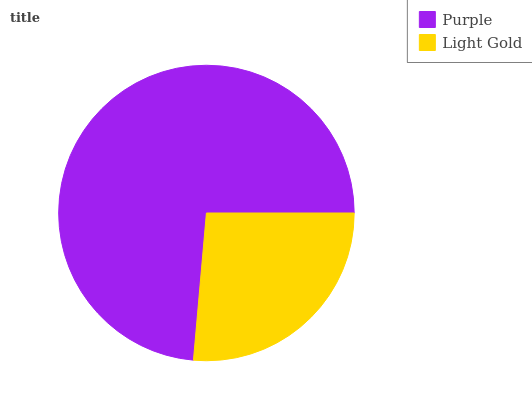Is Light Gold the minimum?
Answer yes or no. Yes. Is Purple the maximum?
Answer yes or no. Yes. Is Light Gold the maximum?
Answer yes or no. No. Is Purple greater than Light Gold?
Answer yes or no. Yes. Is Light Gold less than Purple?
Answer yes or no. Yes. Is Light Gold greater than Purple?
Answer yes or no. No. Is Purple less than Light Gold?
Answer yes or no. No. Is Purple the high median?
Answer yes or no. Yes. Is Light Gold the low median?
Answer yes or no. Yes. Is Light Gold the high median?
Answer yes or no. No. Is Purple the low median?
Answer yes or no. No. 